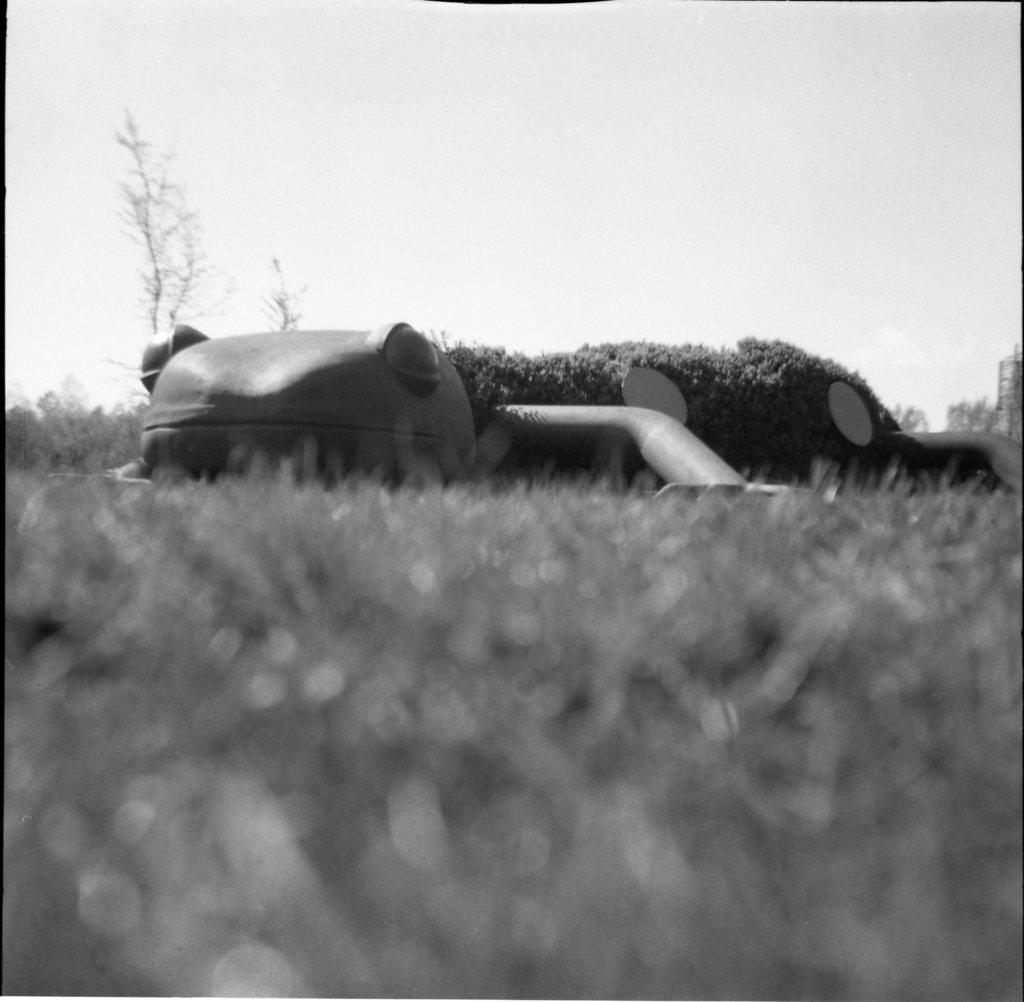What type of picture is in the image? The image contains a black and white picture. What type of natural environment is visible in the picture? There is grass visible in the picture. What shape is the structure in the picture? There is a structure in the shape of a frog in the picture. What else can be seen in the picture besides the grass and the frog-shaped structure? There are trees in the picture, and the sky is visible in the background. What type of animal is the porter carrying on its elbow in the image? There is no animal or porter present in the image. The image features a black and white picture with a frog-shaped structure, trees, grass, and a visible sky. 